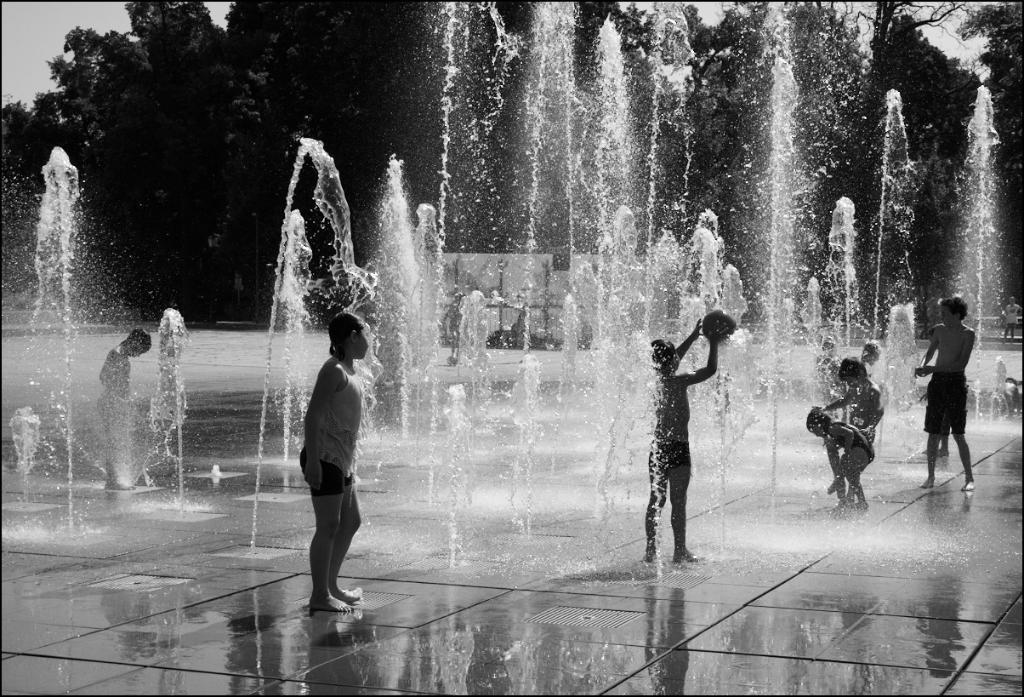What can be seen in the image involving children? There are children in the image, and they are playing in the water. What else is visible in the image besides the children? There are trees visible in the image. Can you see any ghosts interacting with the children in the image? There are no ghosts present in the image; it only features children playing in the water and trees in the background. 